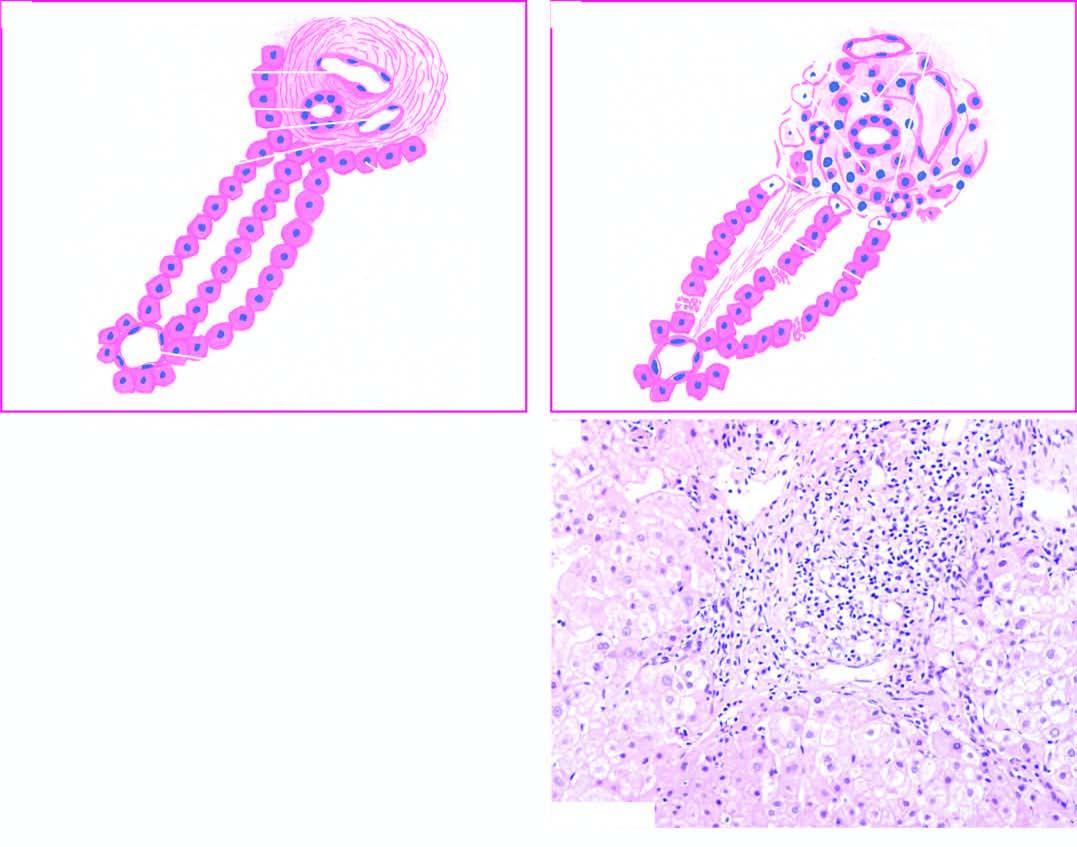does the open wound spur into lobules?
Answer the question using a single word or phrase. No 